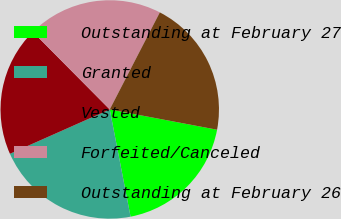<chart> <loc_0><loc_0><loc_500><loc_500><pie_chart><fcel>Outstanding at February 27<fcel>Granted<fcel>Vested<fcel>Forfeited/Canceled<fcel>Outstanding at February 26<nl><fcel>18.98%<fcel>21.4%<fcel>19.22%<fcel>20.02%<fcel>20.39%<nl></chart> 